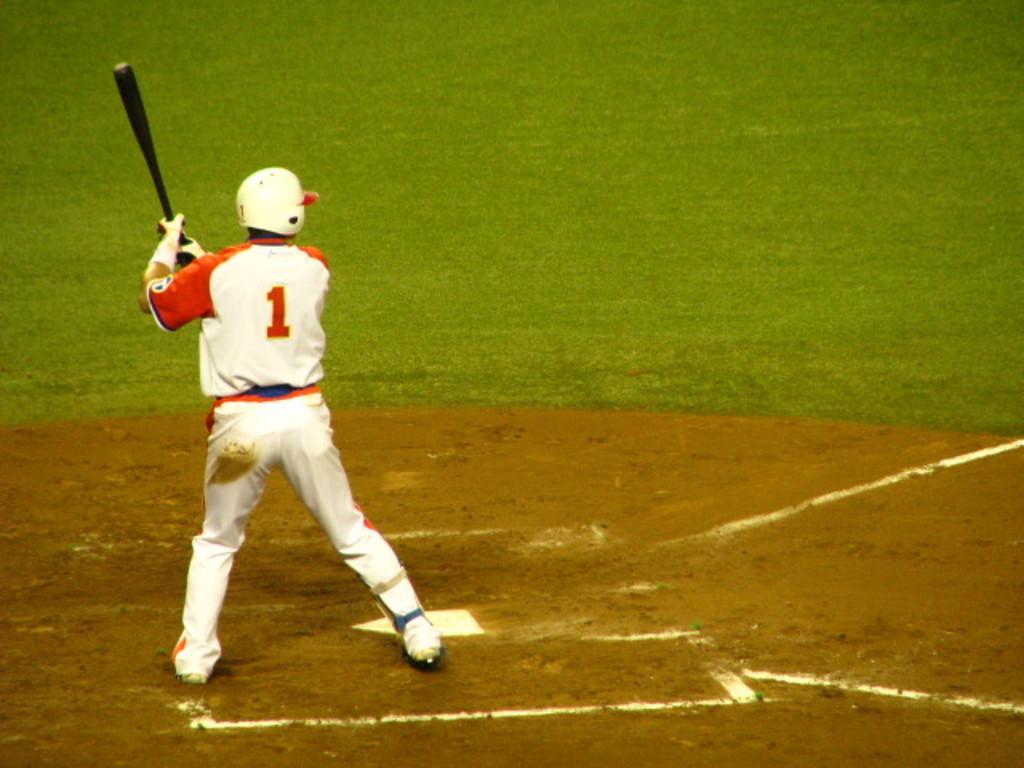How would you summarize this image in a sentence or two? In the image there is a man standing on the ground, he is holding a baseball bat and around the man the land is covered with grass. 